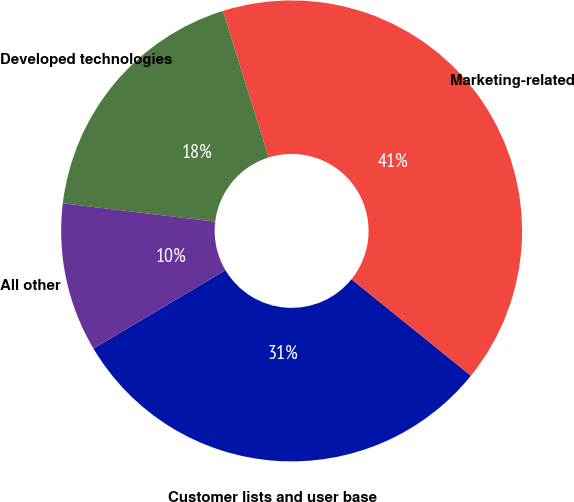Convert chart. <chart><loc_0><loc_0><loc_500><loc_500><pie_chart><fcel>Customer lists and user base<fcel>Marketing-related<fcel>Developed technologies<fcel>All other<nl><fcel>30.66%<fcel>40.63%<fcel>18.27%<fcel>10.44%<nl></chart> 